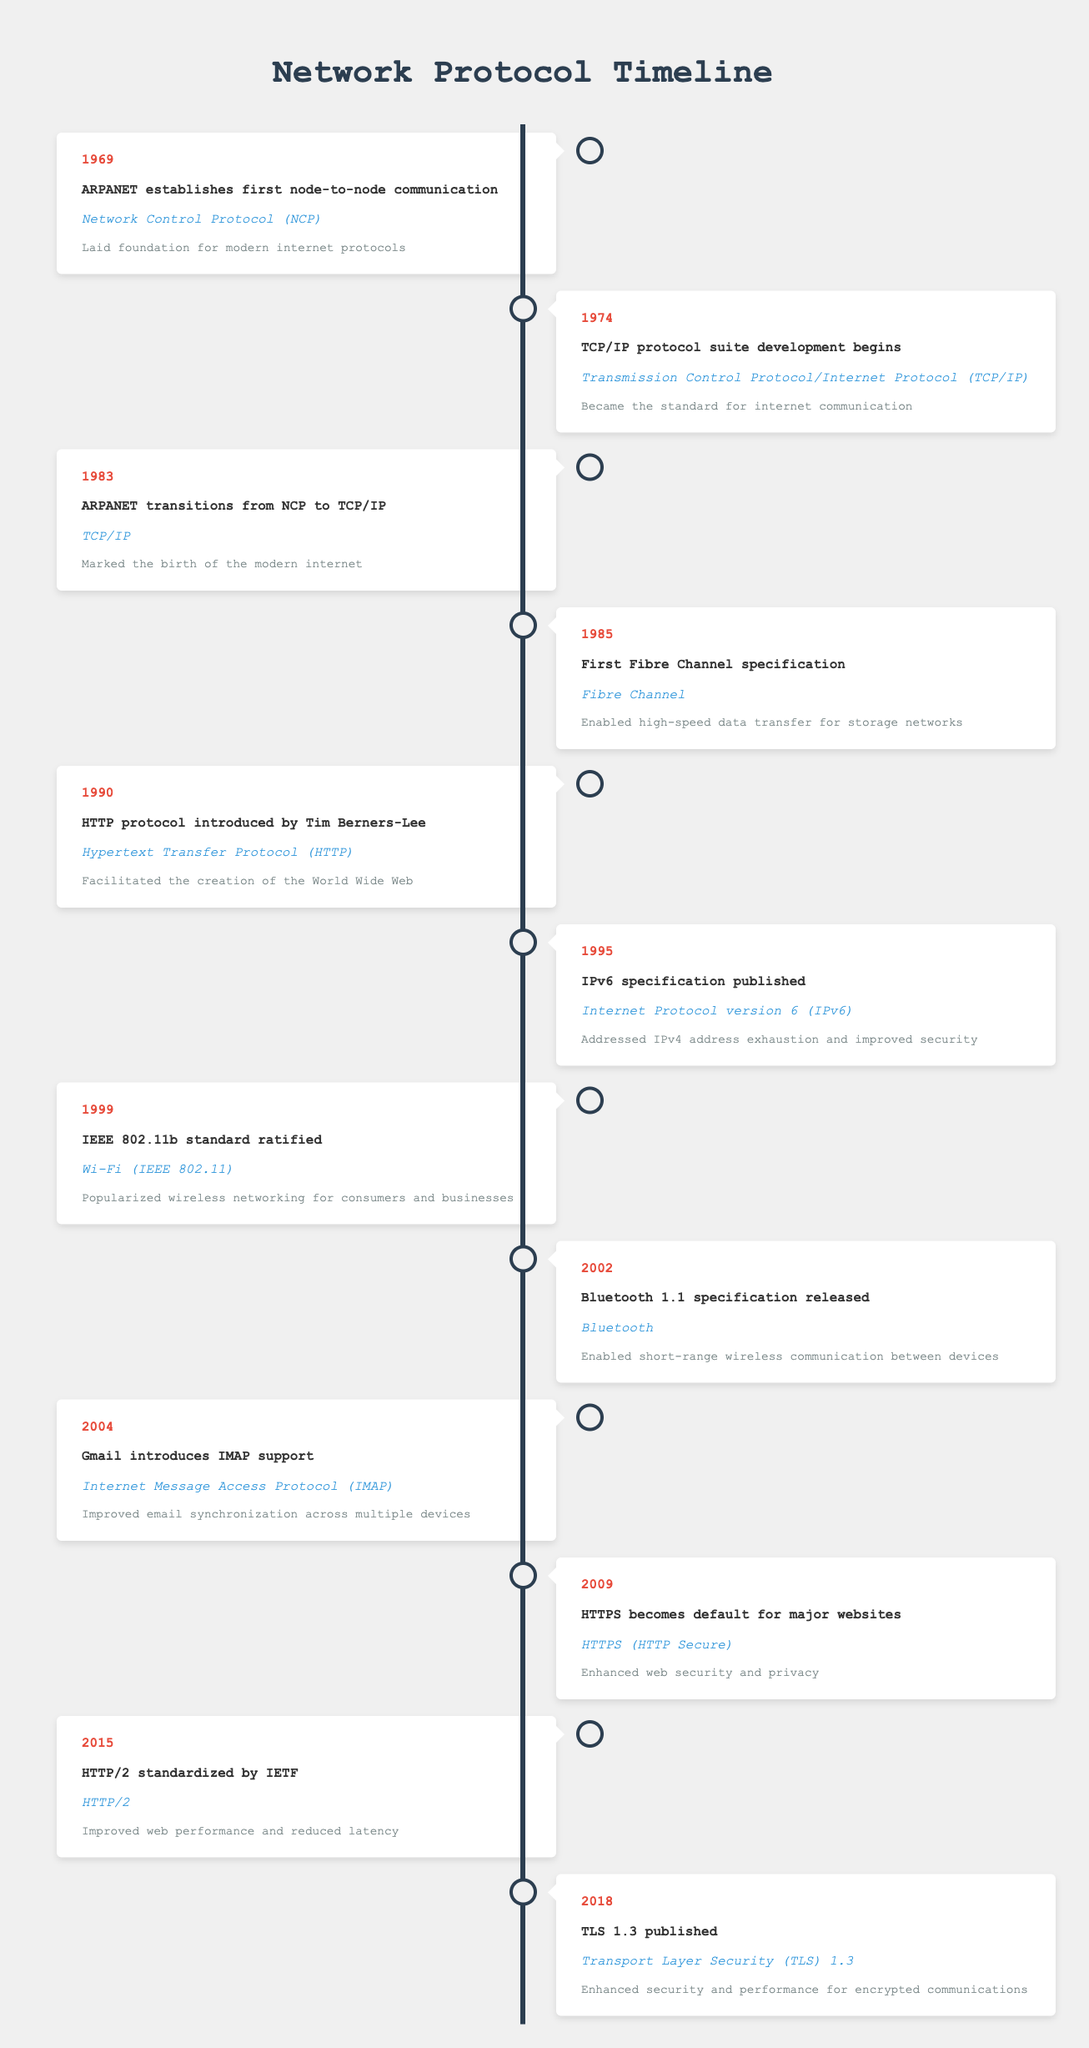What protocol was introduced in 1990? The table indicates that in 1990, the Hypertext Transfer Protocol (HTTP) was introduced by Tim Berners-Lee.
Answer: Hypertext Transfer Protocol (HTTP) Which protocol was adopted first, TCP/IP or Fibre Channel? Referring to the timeline, TCP/IP was developed in 1974 and became the standard by 1983, while Fibre Channel was first specified in 1985. Thus, TCP/IP was adopted earlier.
Answer: TCP/IP What was the significance of the year 2009 regarding internet security? The table states that in 2009, HTTPS became the default for major websites, which significantly enhanced web security and privacy.
Answer: Enhanced web security and privacy How many years passed between the introduction of HTTP and the standardization of HTTP/2? HTTP was introduced in 1990 and HTTP/2 was standardized in 2015. The difference is 2015 - 1990 = 25 years.
Answer: 25 years Did any protocols transition from an earlier version to a newer one, according to the timeline? Yes, the timeline mentions that ARPANET transitioned from Network Control Protocol (NCP) to Transmission Control Protocol/Internet Protocol (TCP/IP) in 1983.
Answer: Yes Which protocol related to wireless networking was ratified in 1999? According to the timeline, the IEEE 802.11b standard, which is related to Wi-Fi, was ratified in 1999.
Answer: Wi-Fi (IEEE 802.11) What is the significance of IPv6 published in 1995? The data shows that the IPv6 specification addressed IPv4 address exhaustion and improved security, highlighting its importance in networking.
Answer: Addressed IPv4 address exhaustion and improved security List protocols introduced after the year 2000. From the timeline, the protocols introduced after 2000 are Bluetooth (2002), IMAP (2004), HTTPS (2009), HTTP/2 (2015), and TLS 1.3 (2018).
Answer: Bluetooth, IMAP, HTTPS, HTTP/2, TLS 1.3 What is the relationship between Bluetooth and short-range communication? The table specifies that the Bluetooth 1.1 specification released in 2002 enabled short-range wireless communication between devices, establishing a direct relationship.
Answer: Enabled short-range wireless communication 